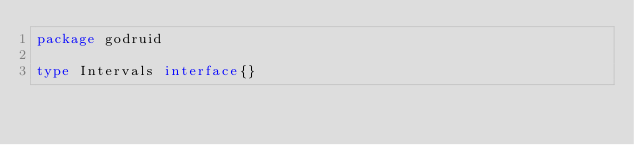<code> <loc_0><loc_0><loc_500><loc_500><_Go_>package godruid

type Intervals interface{}
</code> 